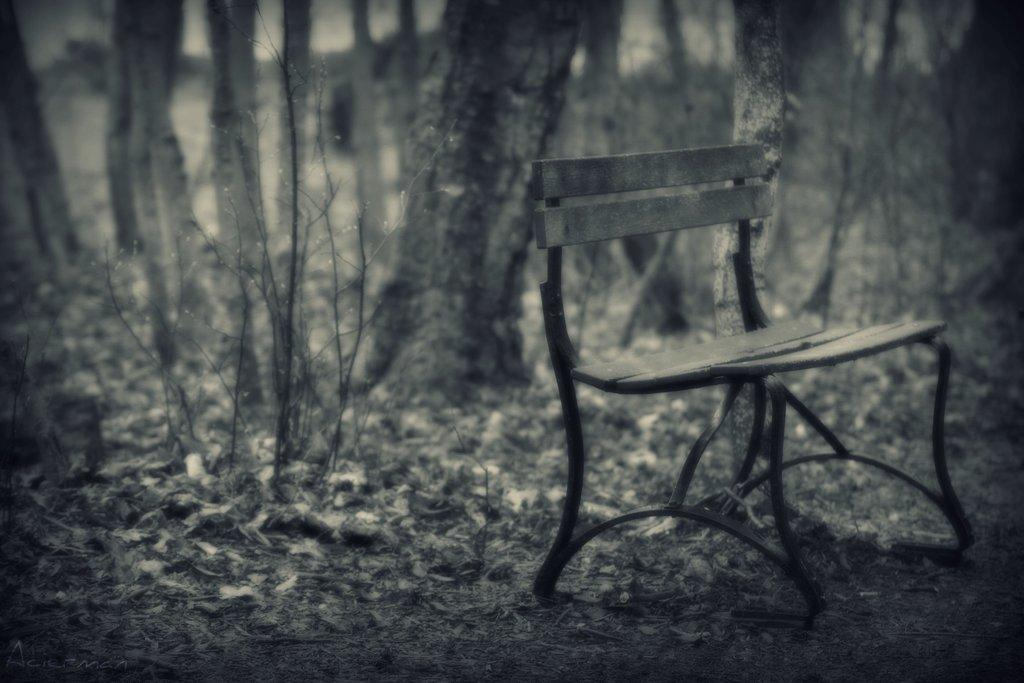What type of seating is present in the image? There is a bench in the image. What can be seen in the distance behind the bench? There are trees in the background of the image. Is there any greenery visible in the image? Yes, there is a plant visible in the image. How does the bench waste energy in the image? The bench does not waste energy in the image, as it is an inanimate object. 